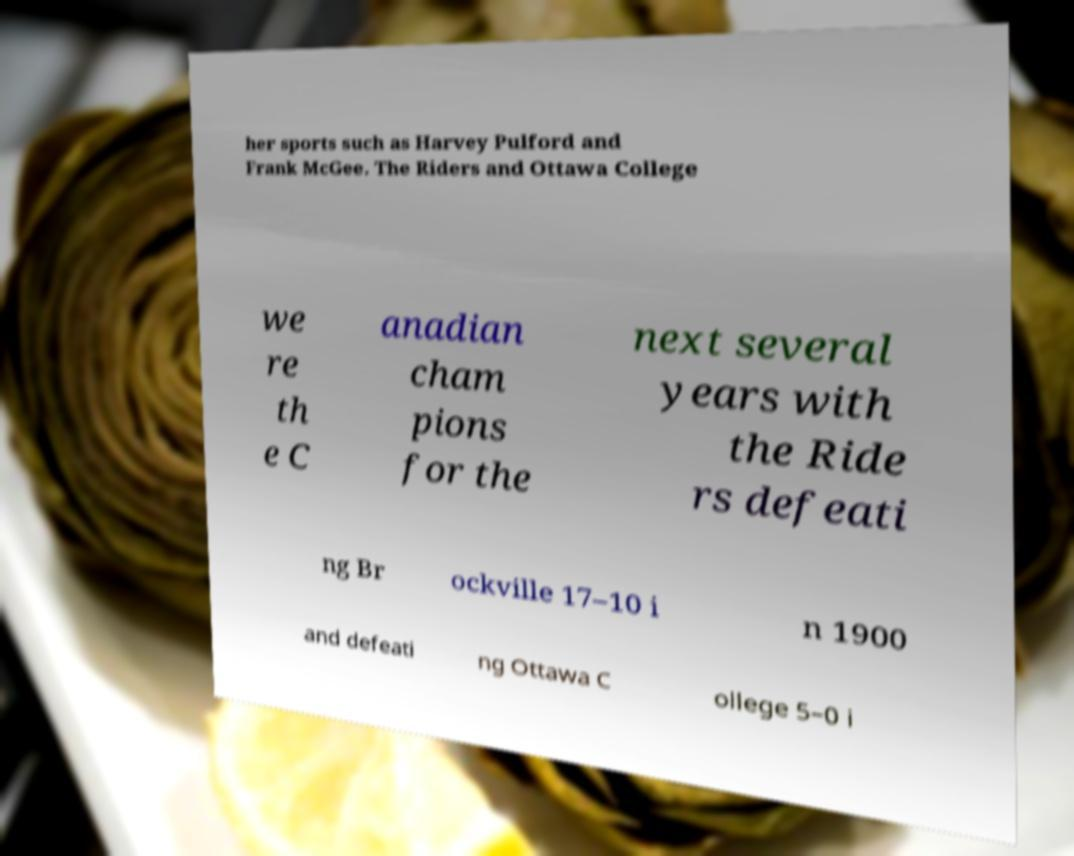There's text embedded in this image that I need extracted. Can you transcribe it verbatim? her sports such as Harvey Pulford and Frank McGee. The Riders and Ottawa College we re th e C anadian cham pions for the next several years with the Ride rs defeati ng Br ockville 17–10 i n 1900 and defeati ng Ottawa C ollege 5–0 i 